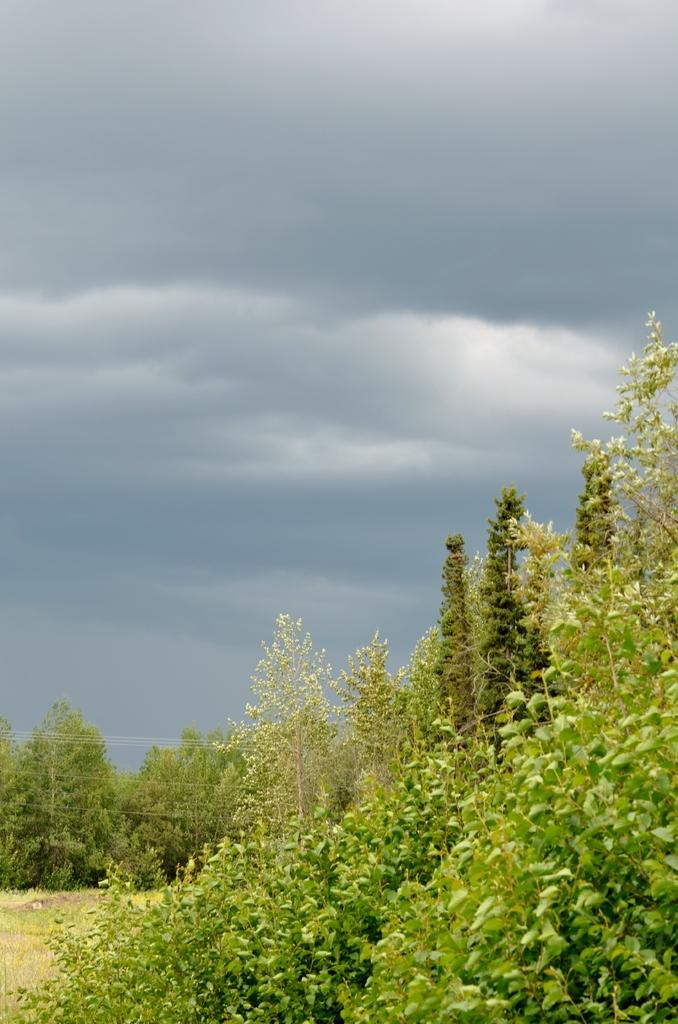What type of natural elements are present in the middle of the image? There are trees and grass in the middle of the image. What else can be seen in the middle of the image besides trees and grass? There are trees and wires in the middle of the image. What is visible at the top of the image? The sky is visible at the top of the image. What type of fuel is being used by the body in the image? There is no body or fuel present in the image. What room is the image taken in? The image does not depict a room; it shows an outdoor scene with trees, grass, and wires. 